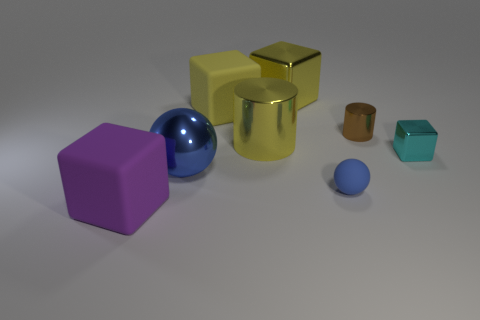There is a metal block behind the metallic block that is in front of the big rubber block right of the purple matte object; what is its size?
Provide a succinct answer. Large. There is a big yellow shiny object right of the big yellow metal thing in front of the brown shiny cylinder; are there any metal things on the left side of it?
Your response must be concise. Yes. Is the number of blue rubber spheres greater than the number of gray metal spheres?
Provide a succinct answer. Yes. What color is the tiny metal thing behind the small cyan cube?
Provide a short and direct response. Brown. Is the number of tiny cyan blocks in front of the large purple matte cube greater than the number of brown shiny cylinders?
Provide a short and direct response. No. Does the tiny cylinder have the same material as the large blue object?
Offer a terse response. Yes. How many other objects are there of the same shape as the tiny rubber thing?
Keep it short and to the point. 1. Are there any other things that are the same material as the big blue ball?
Ensure brevity in your answer.  Yes. The large matte object in front of the big rubber block to the right of the metallic thing that is on the left side of the large yellow matte object is what color?
Keep it short and to the point. Purple. There is a brown object that is on the left side of the cyan metallic block; is its shape the same as the small blue matte thing?
Your answer should be very brief. No. 